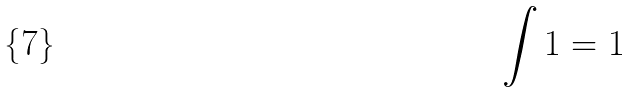<formula> <loc_0><loc_0><loc_500><loc_500>\int 1 = 1</formula> 